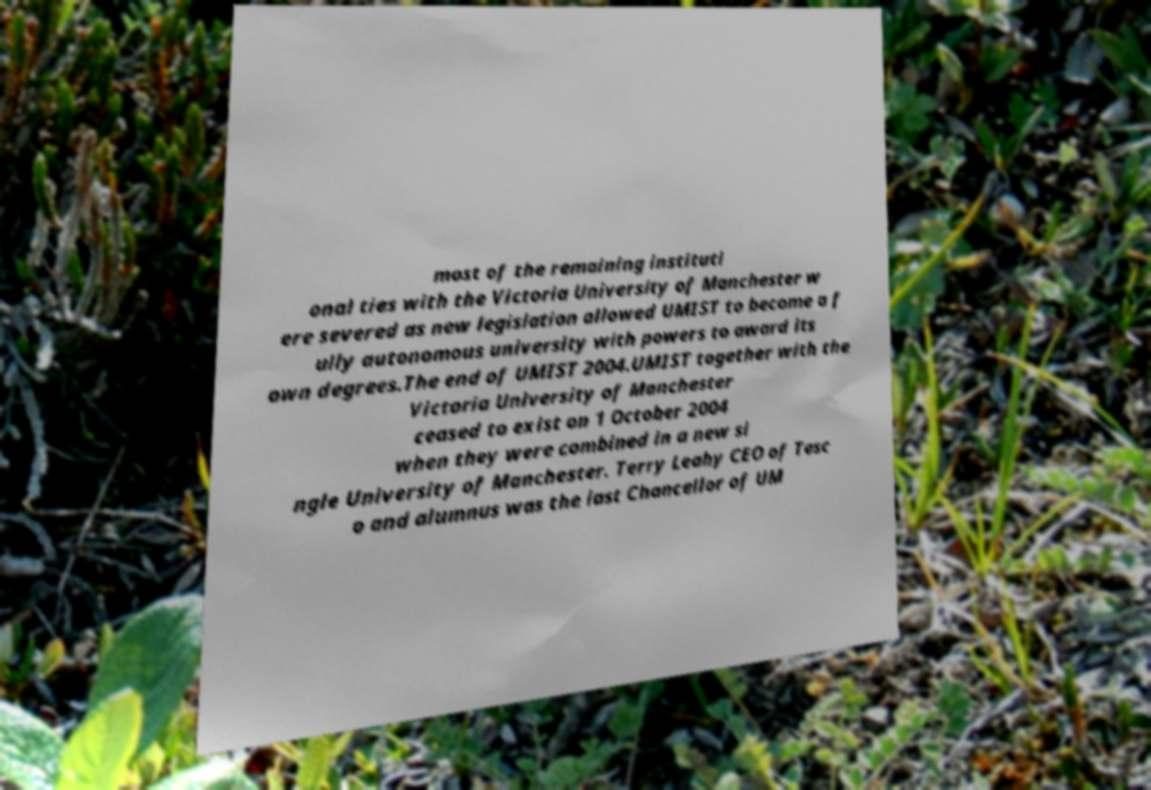Please identify and transcribe the text found in this image. most of the remaining instituti onal ties with the Victoria University of Manchester w ere severed as new legislation allowed UMIST to become a f ully autonomous university with powers to award its own degrees.The end of UMIST 2004.UMIST together with the Victoria University of Manchester ceased to exist on 1 October 2004 when they were combined in a new si ngle University of Manchester. Terry Leahy CEO of Tesc o and alumnus was the last Chancellor of UM 